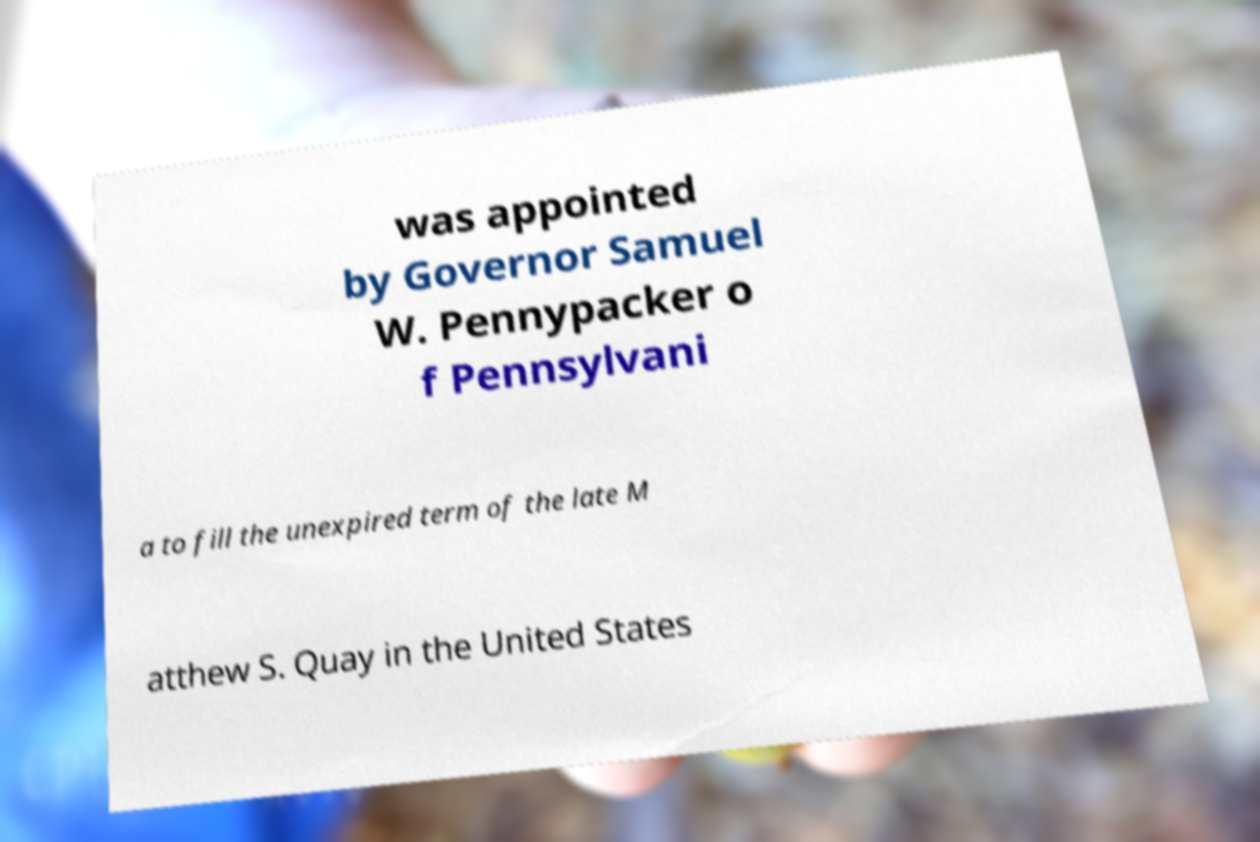Could you assist in decoding the text presented in this image and type it out clearly? was appointed by Governor Samuel W. Pennypacker o f Pennsylvani a to fill the unexpired term of the late M atthew S. Quay in the United States 